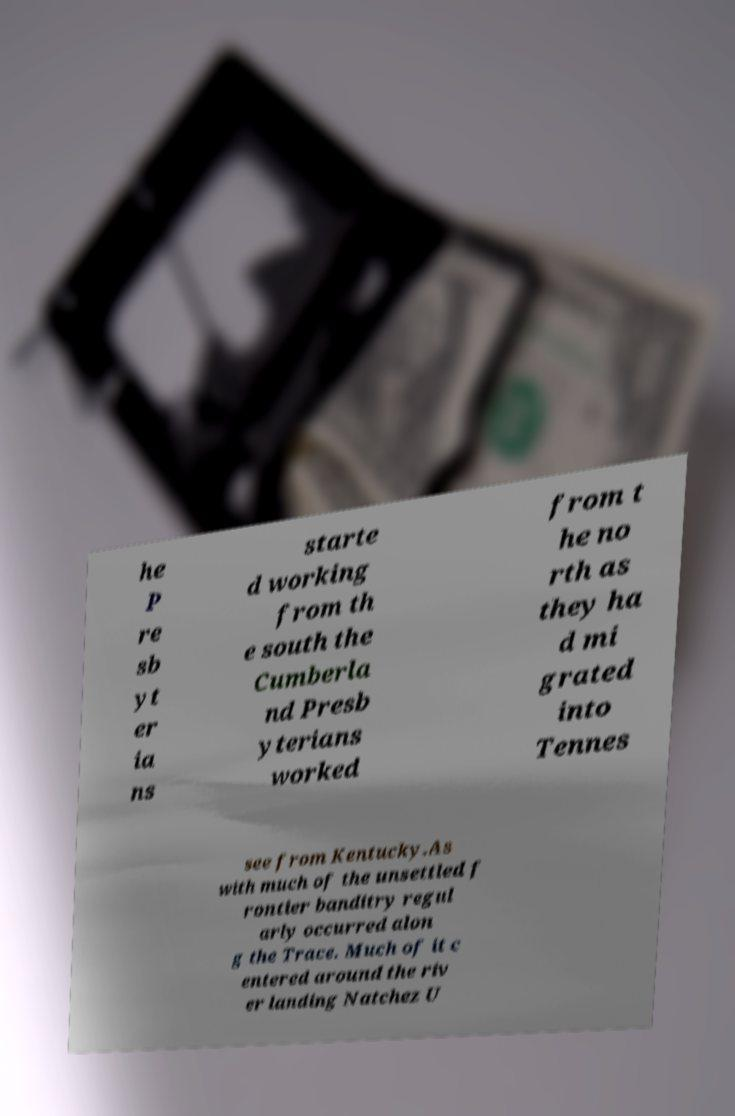What messages or text are displayed in this image? I need them in a readable, typed format. he P re sb yt er ia ns starte d working from th e south the Cumberla nd Presb yterians worked from t he no rth as they ha d mi grated into Tennes see from Kentucky.As with much of the unsettled f rontier banditry regul arly occurred alon g the Trace. Much of it c entered around the riv er landing Natchez U 